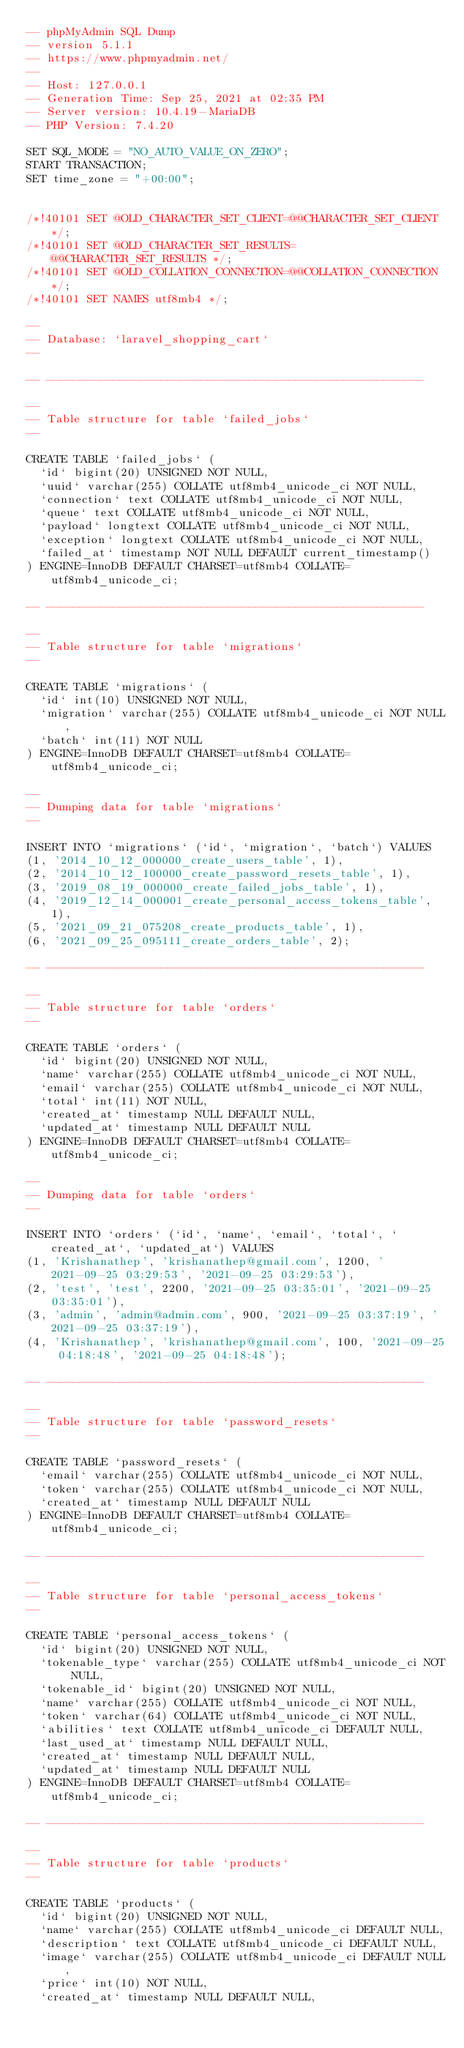<code> <loc_0><loc_0><loc_500><loc_500><_SQL_>-- phpMyAdmin SQL Dump
-- version 5.1.1
-- https://www.phpmyadmin.net/
--
-- Host: 127.0.0.1
-- Generation Time: Sep 25, 2021 at 02:35 PM
-- Server version: 10.4.19-MariaDB
-- PHP Version: 7.4.20

SET SQL_MODE = "NO_AUTO_VALUE_ON_ZERO";
START TRANSACTION;
SET time_zone = "+00:00";


/*!40101 SET @OLD_CHARACTER_SET_CLIENT=@@CHARACTER_SET_CLIENT */;
/*!40101 SET @OLD_CHARACTER_SET_RESULTS=@@CHARACTER_SET_RESULTS */;
/*!40101 SET @OLD_COLLATION_CONNECTION=@@COLLATION_CONNECTION */;
/*!40101 SET NAMES utf8mb4 */;

--
-- Database: `laravel_shopping_cart`
--

-- --------------------------------------------------------

--
-- Table structure for table `failed_jobs`
--

CREATE TABLE `failed_jobs` (
  `id` bigint(20) UNSIGNED NOT NULL,
  `uuid` varchar(255) COLLATE utf8mb4_unicode_ci NOT NULL,
  `connection` text COLLATE utf8mb4_unicode_ci NOT NULL,
  `queue` text COLLATE utf8mb4_unicode_ci NOT NULL,
  `payload` longtext COLLATE utf8mb4_unicode_ci NOT NULL,
  `exception` longtext COLLATE utf8mb4_unicode_ci NOT NULL,
  `failed_at` timestamp NOT NULL DEFAULT current_timestamp()
) ENGINE=InnoDB DEFAULT CHARSET=utf8mb4 COLLATE=utf8mb4_unicode_ci;

-- --------------------------------------------------------

--
-- Table structure for table `migrations`
--

CREATE TABLE `migrations` (
  `id` int(10) UNSIGNED NOT NULL,
  `migration` varchar(255) COLLATE utf8mb4_unicode_ci NOT NULL,
  `batch` int(11) NOT NULL
) ENGINE=InnoDB DEFAULT CHARSET=utf8mb4 COLLATE=utf8mb4_unicode_ci;

--
-- Dumping data for table `migrations`
--

INSERT INTO `migrations` (`id`, `migration`, `batch`) VALUES
(1, '2014_10_12_000000_create_users_table', 1),
(2, '2014_10_12_100000_create_password_resets_table', 1),
(3, '2019_08_19_000000_create_failed_jobs_table', 1),
(4, '2019_12_14_000001_create_personal_access_tokens_table', 1),
(5, '2021_09_21_075208_create_products_table', 1),
(6, '2021_09_25_095111_create_orders_table', 2);

-- --------------------------------------------------------

--
-- Table structure for table `orders`
--

CREATE TABLE `orders` (
  `id` bigint(20) UNSIGNED NOT NULL,
  `name` varchar(255) COLLATE utf8mb4_unicode_ci NOT NULL,
  `email` varchar(255) COLLATE utf8mb4_unicode_ci NOT NULL,
  `total` int(11) NOT NULL,
  `created_at` timestamp NULL DEFAULT NULL,
  `updated_at` timestamp NULL DEFAULT NULL
) ENGINE=InnoDB DEFAULT CHARSET=utf8mb4 COLLATE=utf8mb4_unicode_ci;

--
-- Dumping data for table `orders`
--

INSERT INTO `orders` (`id`, `name`, `email`, `total`, `created_at`, `updated_at`) VALUES
(1, 'Krishanathep', 'krishanathep@gmail.com', 1200, '2021-09-25 03:29:53', '2021-09-25 03:29:53'),
(2, 'test', 'test', 2200, '2021-09-25 03:35:01', '2021-09-25 03:35:01'),
(3, 'admin', 'admin@admin.com', 900, '2021-09-25 03:37:19', '2021-09-25 03:37:19'),
(4, 'Krishanathep', 'krishanathep@gmail.com', 100, '2021-09-25 04:18:48', '2021-09-25 04:18:48');

-- --------------------------------------------------------

--
-- Table structure for table `password_resets`
--

CREATE TABLE `password_resets` (
  `email` varchar(255) COLLATE utf8mb4_unicode_ci NOT NULL,
  `token` varchar(255) COLLATE utf8mb4_unicode_ci NOT NULL,
  `created_at` timestamp NULL DEFAULT NULL
) ENGINE=InnoDB DEFAULT CHARSET=utf8mb4 COLLATE=utf8mb4_unicode_ci;

-- --------------------------------------------------------

--
-- Table structure for table `personal_access_tokens`
--

CREATE TABLE `personal_access_tokens` (
  `id` bigint(20) UNSIGNED NOT NULL,
  `tokenable_type` varchar(255) COLLATE utf8mb4_unicode_ci NOT NULL,
  `tokenable_id` bigint(20) UNSIGNED NOT NULL,
  `name` varchar(255) COLLATE utf8mb4_unicode_ci NOT NULL,
  `token` varchar(64) COLLATE utf8mb4_unicode_ci NOT NULL,
  `abilities` text COLLATE utf8mb4_unicode_ci DEFAULT NULL,
  `last_used_at` timestamp NULL DEFAULT NULL,
  `created_at` timestamp NULL DEFAULT NULL,
  `updated_at` timestamp NULL DEFAULT NULL
) ENGINE=InnoDB DEFAULT CHARSET=utf8mb4 COLLATE=utf8mb4_unicode_ci;

-- --------------------------------------------------------

--
-- Table structure for table `products`
--

CREATE TABLE `products` (
  `id` bigint(20) UNSIGNED NOT NULL,
  `name` varchar(255) COLLATE utf8mb4_unicode_ci DEFAULT NULL,
  `description` text COLLATE utf8mb4_unicode_ci DEFAULT NULL,
  `image` varchar(255) COLLATE utf8mb4_unicode_ci DEFAULT NULL,
  `price` int(10) NOT NULL,
  `created_at` timestamp NULL DEFAULT NULL,</code> 